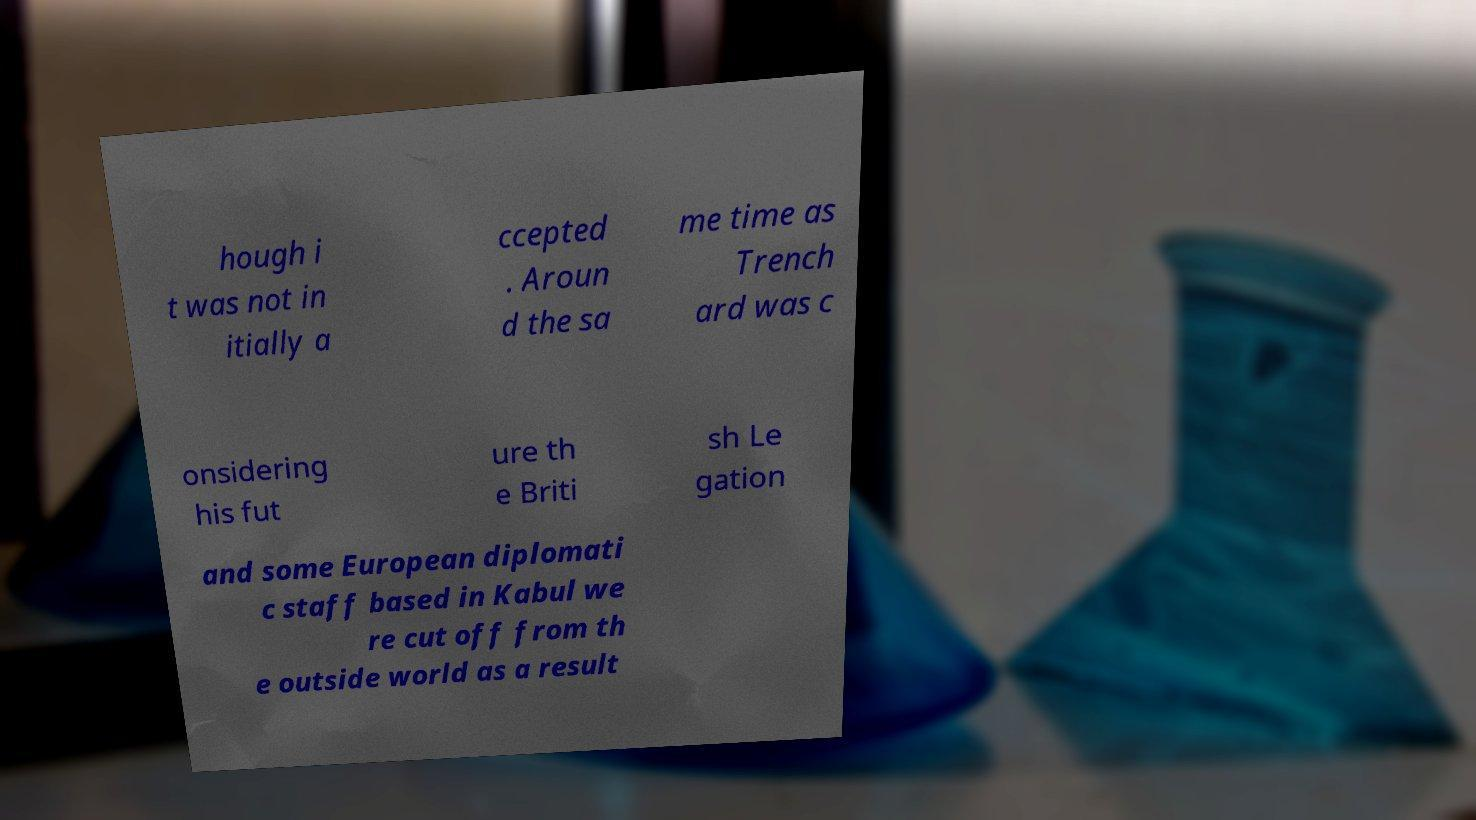Please identify and transcribe the text found in this image. hough i t was not in itially a ccepted . Aroun d the sa me time as Trench ard was c onsidering his fut ure th e Briti sh Le gation and some European diplomati c staff based in Kabul we re cut off from th e outside world as a result 